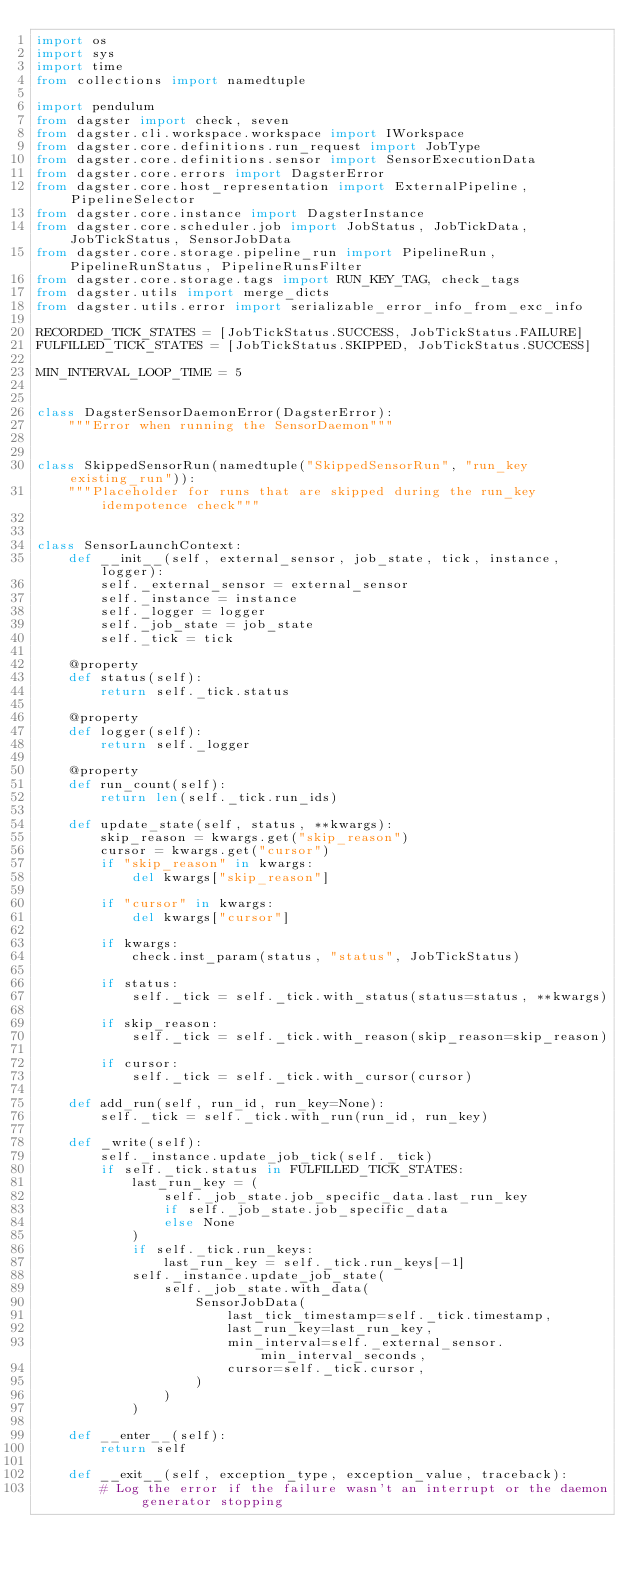Convert code to text. <code><loc_0><loc_0><loc_500><loc_500><_Python_>import os
import sys
import time
from collections import namedtuple

import pendulum
from dagster import check, seven
from dagster.cli.workspace.workspace import IWorkspace
from dagster.core.definitions.run_request import JobType
from dagster.core.definitions.sensor import SensorExecutionData
from dagster.core.errors import DagsterError
from dagster.core.host_representation import ExternalPipeline, PipelineSelector
from dagster.core.instance import DagsterInstance
from dagster.core.scheduler.job import JobStatus, JobTickData, JobTickStatus, SensorJobData
from dagster.core.storage.pipeline_run import PipelineRun, PipelineRunStatus, PipelineRunsFilter
from dagster.core.storage.tags import RUN_KEY_TAG, check_tags
from dagster.utils import merge_dicts
from dagster.utils.error import serializable_error_info_from_exc_info

RECORDED_TICK_STATES = [JobTickStatus.SUCCESS, JobTickStatus.FAILURE]
FULFILLED_TICK_STATES = [JobTickStatus.SKIPPED, JobTickStatus.SUCCESS]

MIN_INTERVAL_LOOP_TIME = 5


class DagsterSensorDaemonError(DagsterError):
    """Error when running the SensorDaemon"""


class SkippedSensorRun(namedtuple("SkippedSensorRun", "run_key existing_run")):
    """Placeholder for runs that are skipped during the run_key idempotence check"""


class SensorLaunchContext:
    def __init__(self, external_sensor, job_state, tick, instance, logger):
        self._external_sensor = external_sensor
        self._instance = instance
        self._logger = logger
        self._job_state = job_state
        self._tick = tick

    @property
    def status(self):
        return self._tick.status

    @property
    def logger(self):
        return self._logger

    @property
    def run_count(self):
        return len(self._tick.run_ids)

    def update_state(self, status, **kwargs):
        skip_reason = kwargs.get("skip_reason")
        cursor = kwargs.get("cursor")
        if "skip_reason" in kwargs:
            del kwargs["skip_reason"]

        if "cursor" in kwargs:
            del kwargs["cursor"]

        if kwargs:
            check.inst_param(status, "status", JobTickStatus)

        if status:
            self._tick = self._tick.with_status(status=status, **kwargs)

        if skip_reason:
            self._tick = self._tick.with_reason(skip_reason=skip_reason)

        if cursor:
            self._tick = self._tick.with_cursor(cursor)

    def add_run(self, run_id, run_key=None):
        self._tick = self._tick.with_run(run_id, run_key)

    def _write(self):
        self._instance.update_job_tick(self._tick)
        if self._tick.status in FULFILLED_TICK_STATES:
            last_run_key = (
                self._job_state.job_specific_data.last_run_key
                if self._job_state.job_specific_data
                else None
            )
            if self._tick.run_keys:
                last_run_key = self._tick.run_keys[-1]
            self._instance.update_job_state(
                self._job_state.with_data(
                    SensorJobData(
                        last_tick_timestamp=self._tick.timestamp,
                        last_run_key=last_run_key,
                        min_interval=self._external_sensor.min_interval_seconds,
                        cursor=self._tick.cursor,
                    )
                )
            )

    def __enter__(self):
        return self

    def __exit__(self, exception_type, exception_value, traceback):
        # Log the error if the failure wasn't an interrupt or the daemon generator stopping</code> 